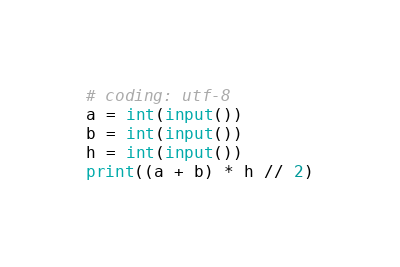<code> <loc_0><loc_0><loc_500><loc_500><_Python_># coding: utf-8
a = int(input())
b = int(input())
h = int(input())
print((a + b) * h // 2)
</code> 